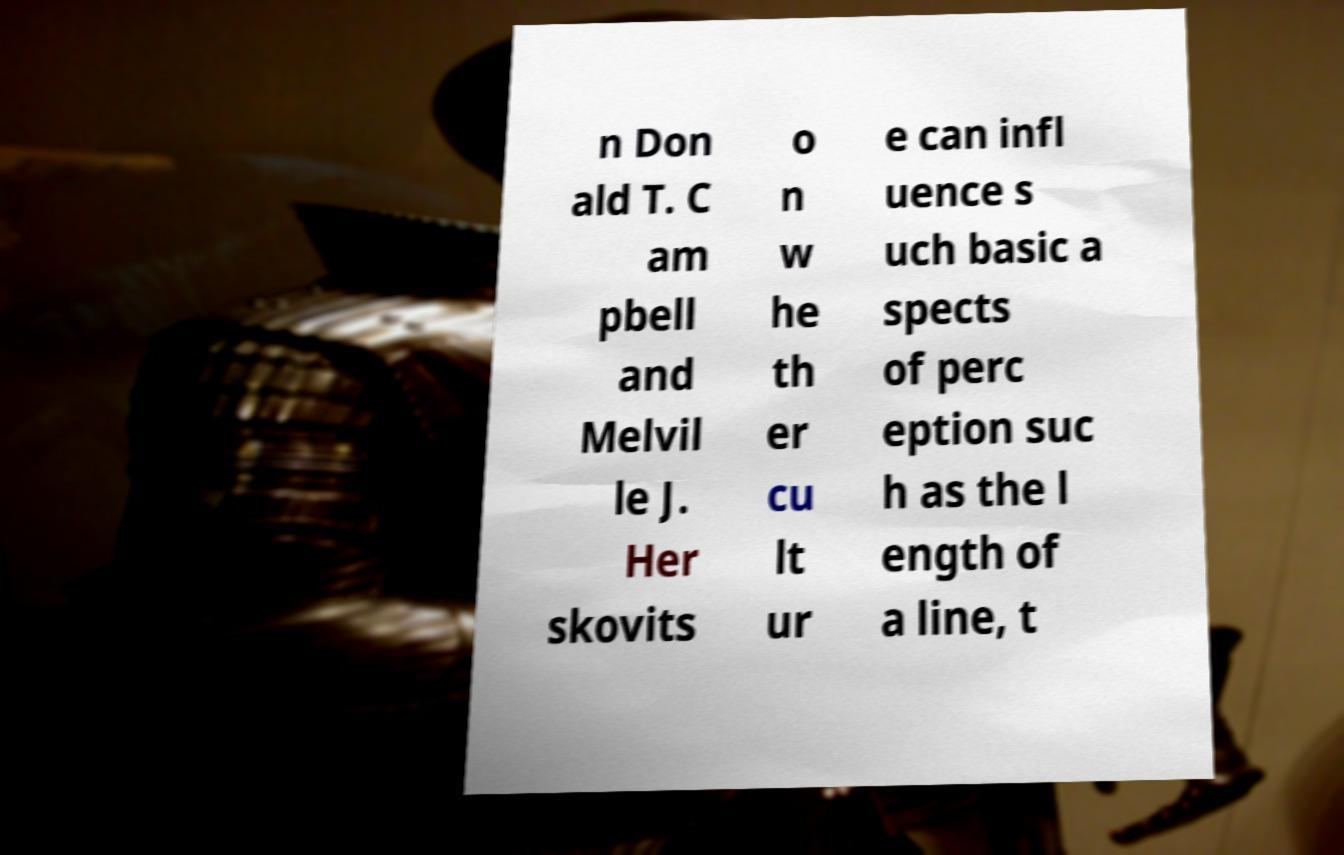I need the written content from this picture converted into text. Can you do that? n Don ald T. C am pbell and Melvil le J. Her skovits o n w he th er cu lt ur e can infl uence s uch basic a spects of perc eption suc h as the l ength of a line, t 